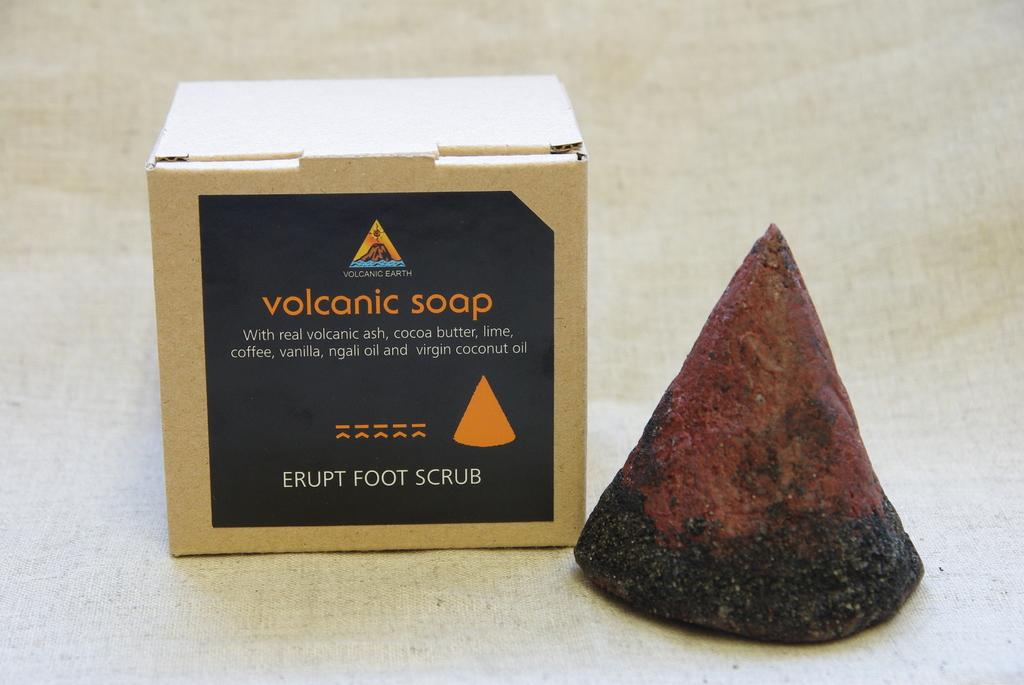What type of object is in the image that is made of stone? There is a stone in the image. What is the other object in the image that has text on it? There is a box with text in the image. What type of dress is hanging on the tree in the image? There is no dress or tree present in the image; it only features a stone and a box with text. What story is being told by the objects in the image? The image does not tell a story; it simply shows a stone and a box with text. 